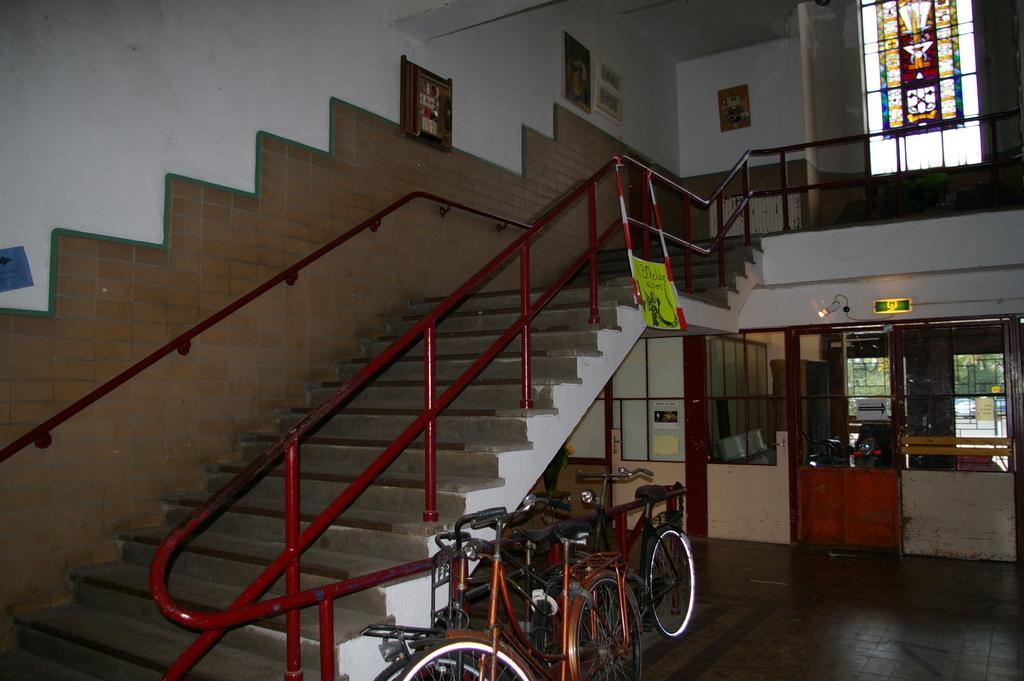Describe this image in one or two sentences. At the bottom of the image there are bicycles. Behind them there are steps with railings. And on the wall there are frames and there is a rod. And also there is a glass wall with design on it. On the right side of the image there are glass walls and doors. 